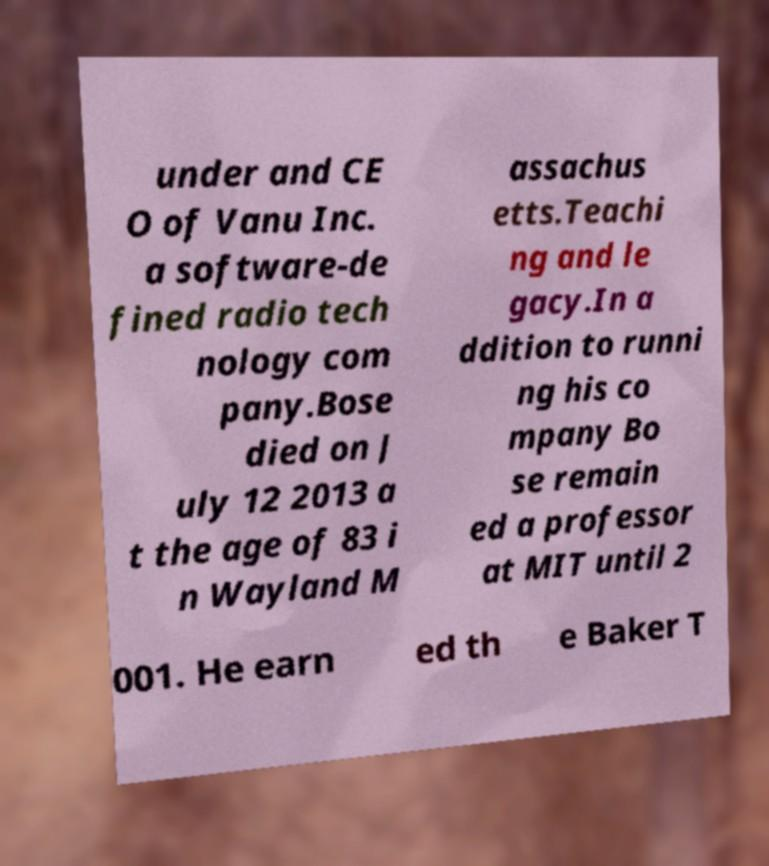I need the written content from this picture converted into text. Can you do that? under and CE O of Vanu Inc. a software-de fined radio tech nology com pany.Bose died on J uly 12 2013 a t the age of 83 i n Wayland M assachus etts.Teachi ng and le gacy.In a ddition to runni ng his co mpany Bo se remain ed a professor at MIT until 2 001. He earn ed th e Baker T 